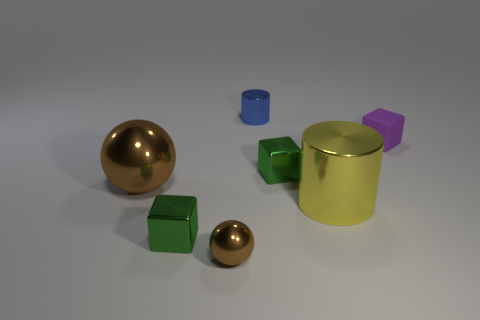How does the arrangement of these objects in the space give off a certain aesthetic or mood? The arrangement of these objects is almost like a carefully composed still life. There is a balance and spacing that gives it a calm and orderly feel. The variety of geometric shapes paired with the contrasting colors adds to an aesthetic that is both visually interesting and harmoniously put together. 